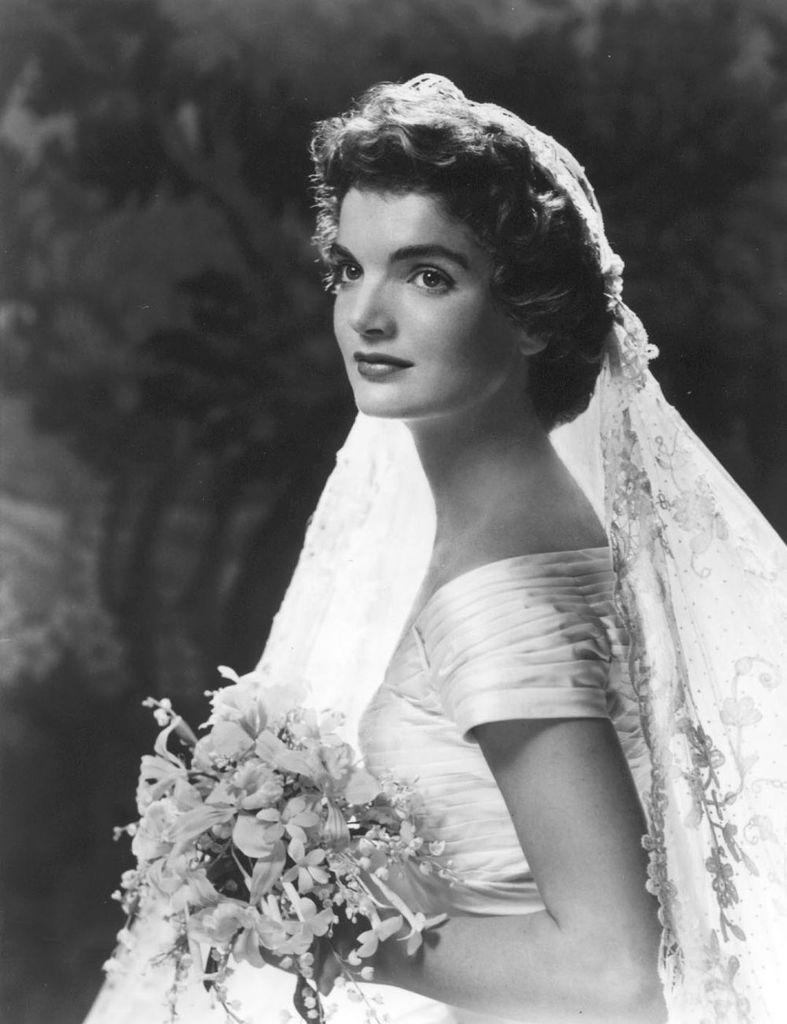Who is present in the image? There is a woman in the image. What is the woman wearing? The woman is wearing a white dress. What is the woman holding in the image? The woman is holding flowers. What can be seen in the background of the image? There are trees in the background of the image. Is there a volcano erupting in the background of the image? No, there is no volcano present in the image. 